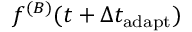Convert formula to latex. <formula><loc_0><loc_0><loc_500><loc_500>f ^ { ( B ) } ( t + \Delta t _ { a d a p t } )</formula> 